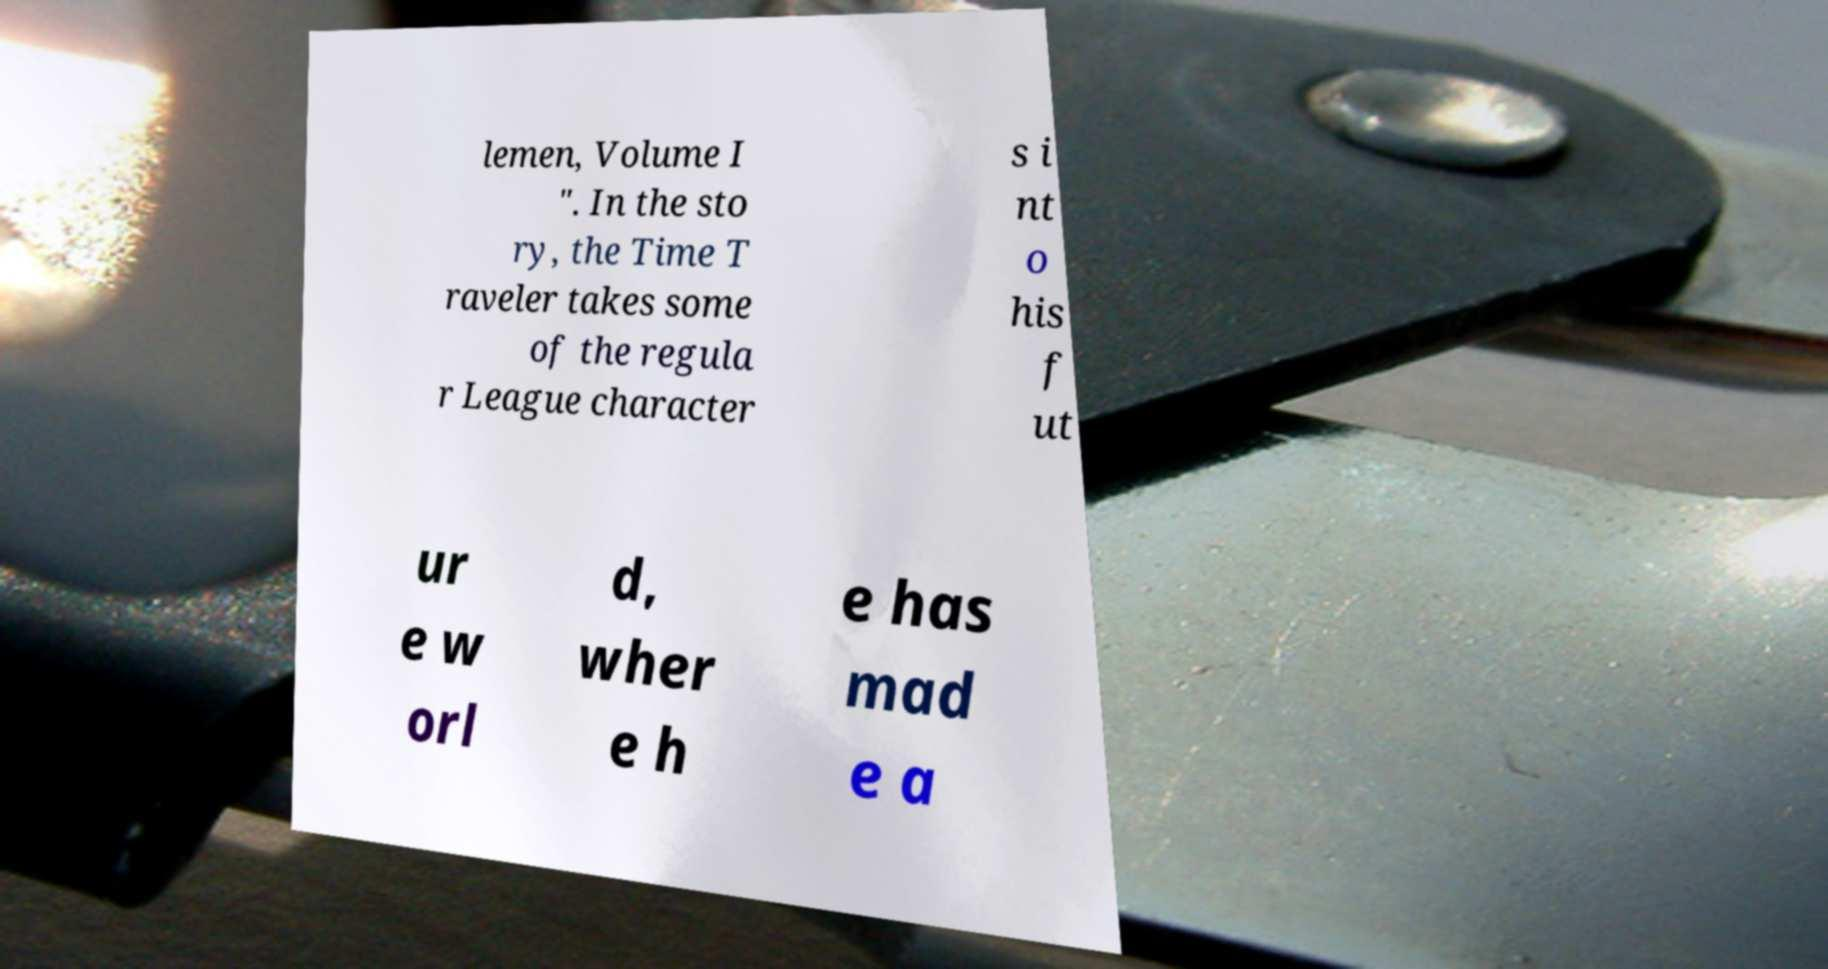For documentation purposes, I need the text within this image transcribed. Could you provide that? lemen, Volume I ". In the sto ry, the Time T raveler takes some of the regula r League character s i nt o his f ut ur e w orl d, wher e h e has mad e a 